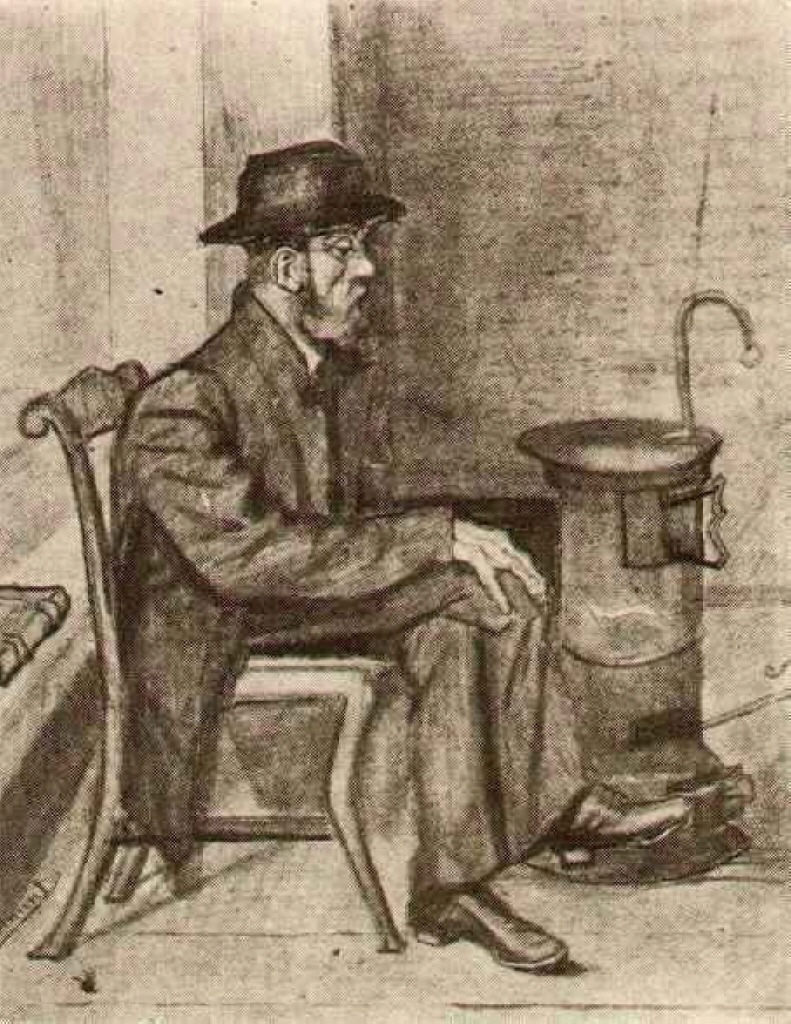What could symbolize the stove beyond its practical use? Beyond its practical use, the stove could symbolize warmth and sustenance, acting as a metaphor for the man's resilience and the enduring spirit of the working class. It represents a beacon of comfort amidst the cold, hard realities of life, highlighting the vital role of such modest, everyday objects in providing not just physical heat but emotional warmth as well. The stove might also signify a focal point of family gatherings, storytelling, and shared meals, encapsulating the essence of home and belonging. 